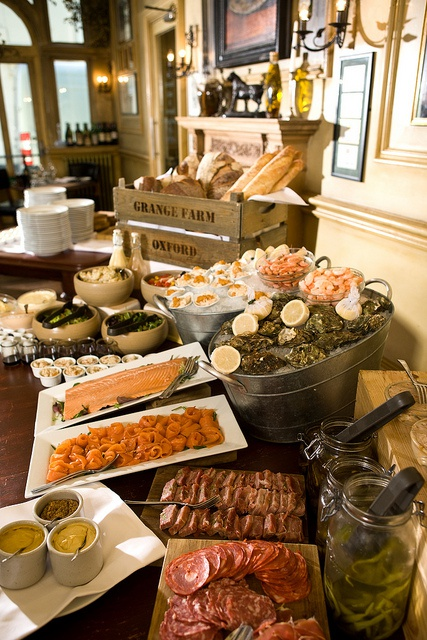Describe the objects in this image and their specific colors. I can see dining table in black, maroon, and brown tones, cup in black, olive, orange, and tan tones, cup in black, olive, gray, and tan tones, bowl in black, olive, and tan tones, and bowl in black, olive, and tan tones in this image. 